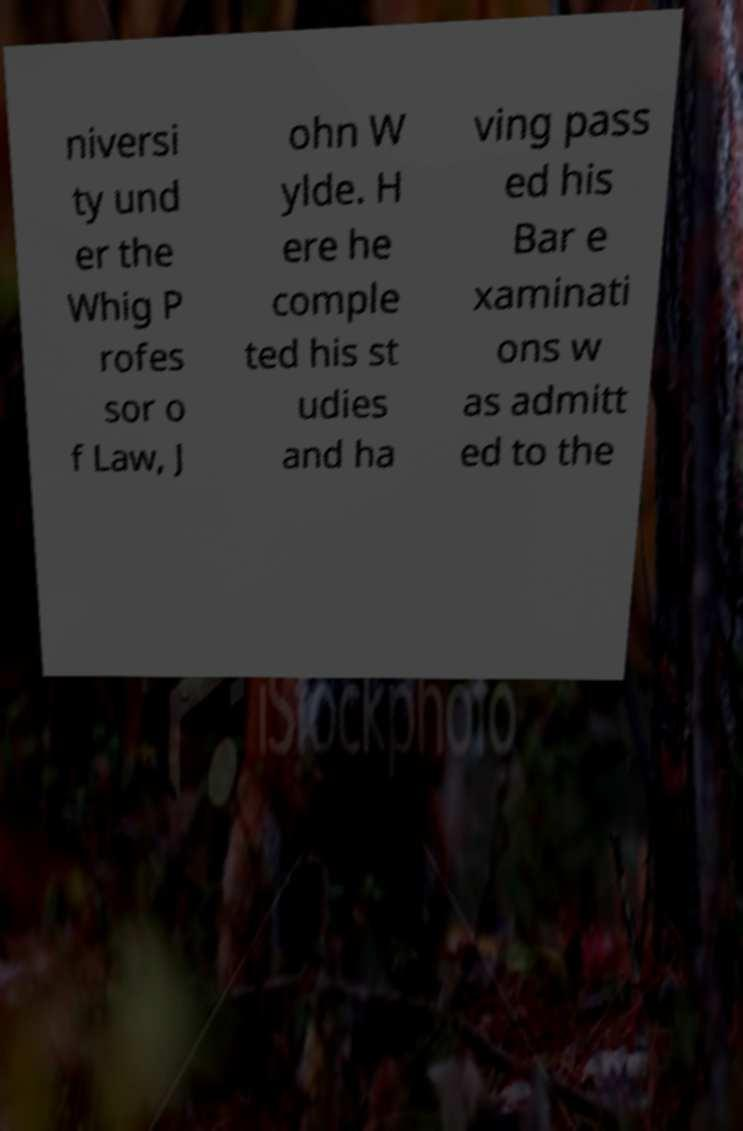Please read and relay the text visible in this image. What does it say? niversi ty und er the Whig P rofes sor o f Law, J ohn W ylde. H ere he comple ted his st udies and ha ving pass ed his Bar e xaminati ons w as admitt ed to the 